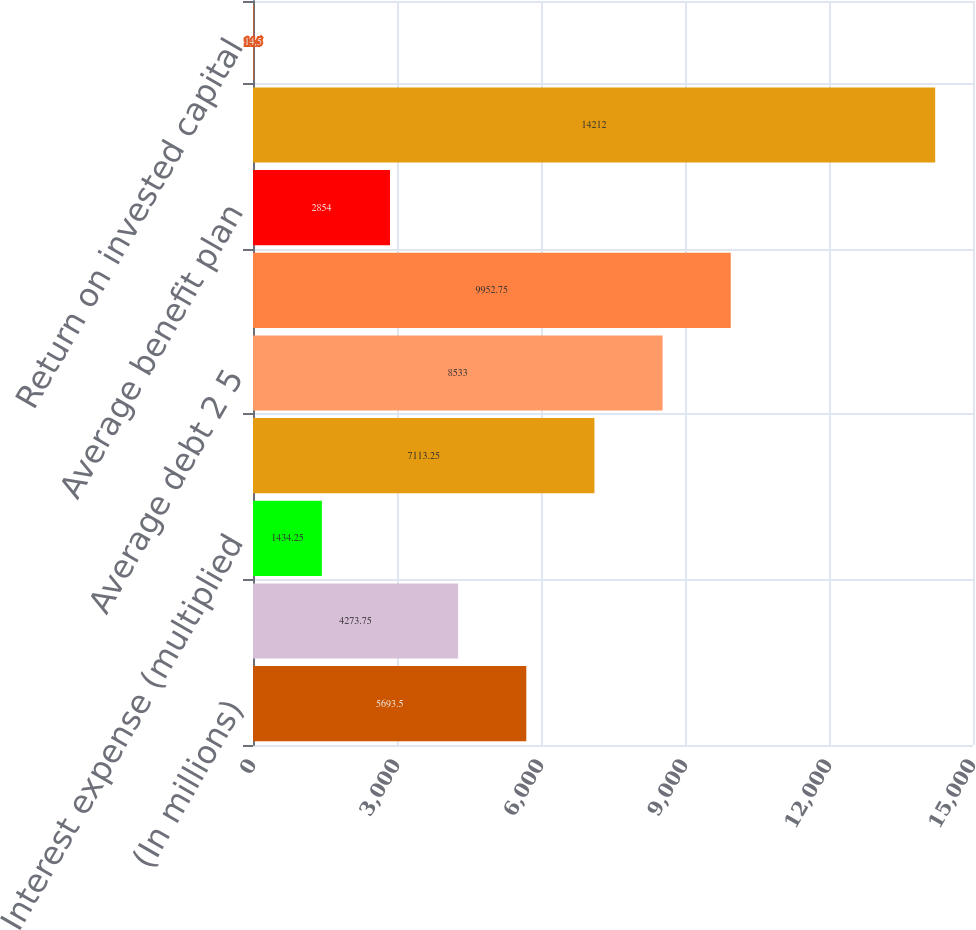Convert chart to OTSL. <chart><loc_0><loc_0><loc_500><loc_500><bar_chart><fcel>(In millions)<fcel>Net earnings<fcel>Interest expense (multiplied<fcel>Return<fcel>Average debt 2 5<fcel>Average equity 3 5<fcel>Average benefit plan<fcel>Average invested capital<fcel>Return on invested capital<nl><fcel>5693.5<fcel>4273.75<fcel>1434.25<fcel>7113.25<fcel>8533<fcel>9952.75<fcel>2854<fcel>14212<fcel>14.5<nl></chart> 